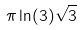Convert formula to latex. <formula><loc_0><loc_0><loc_500><loc_500>\pi \ln ( 3 ) \sqrt { 3 }</formula> 